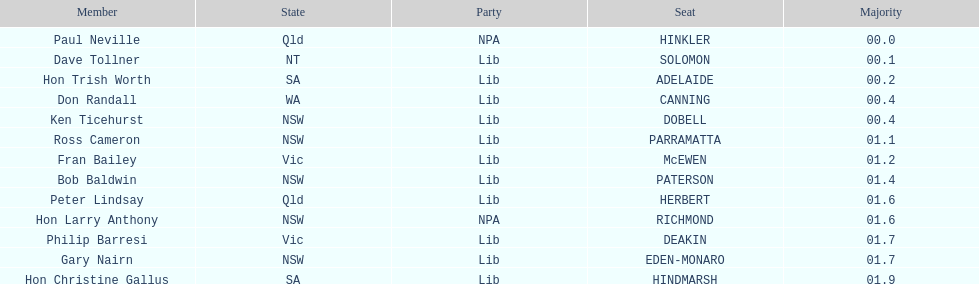What was the total majority that the dobell seat had? 00.4. 